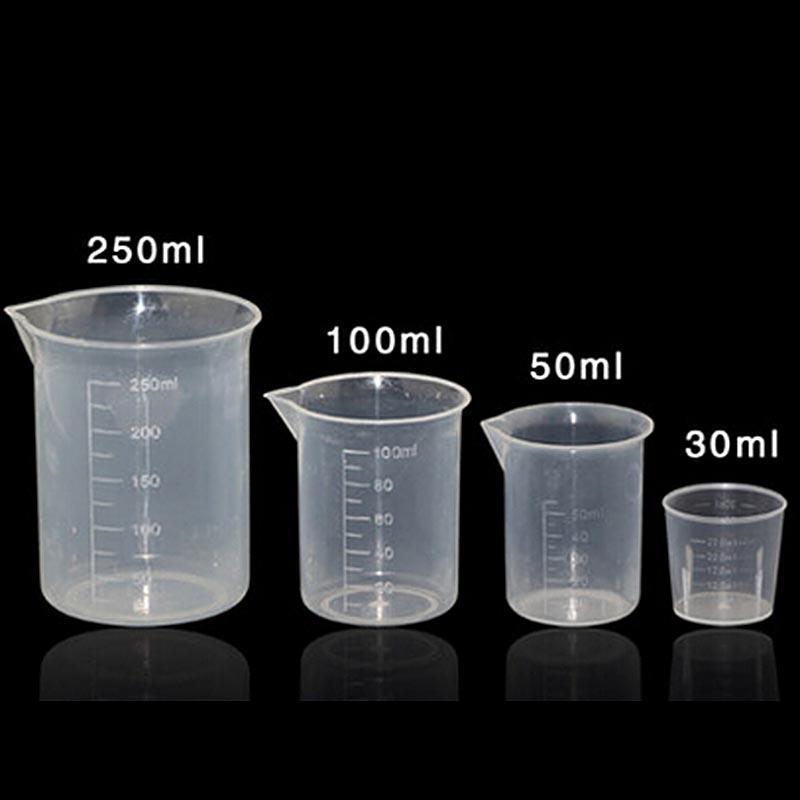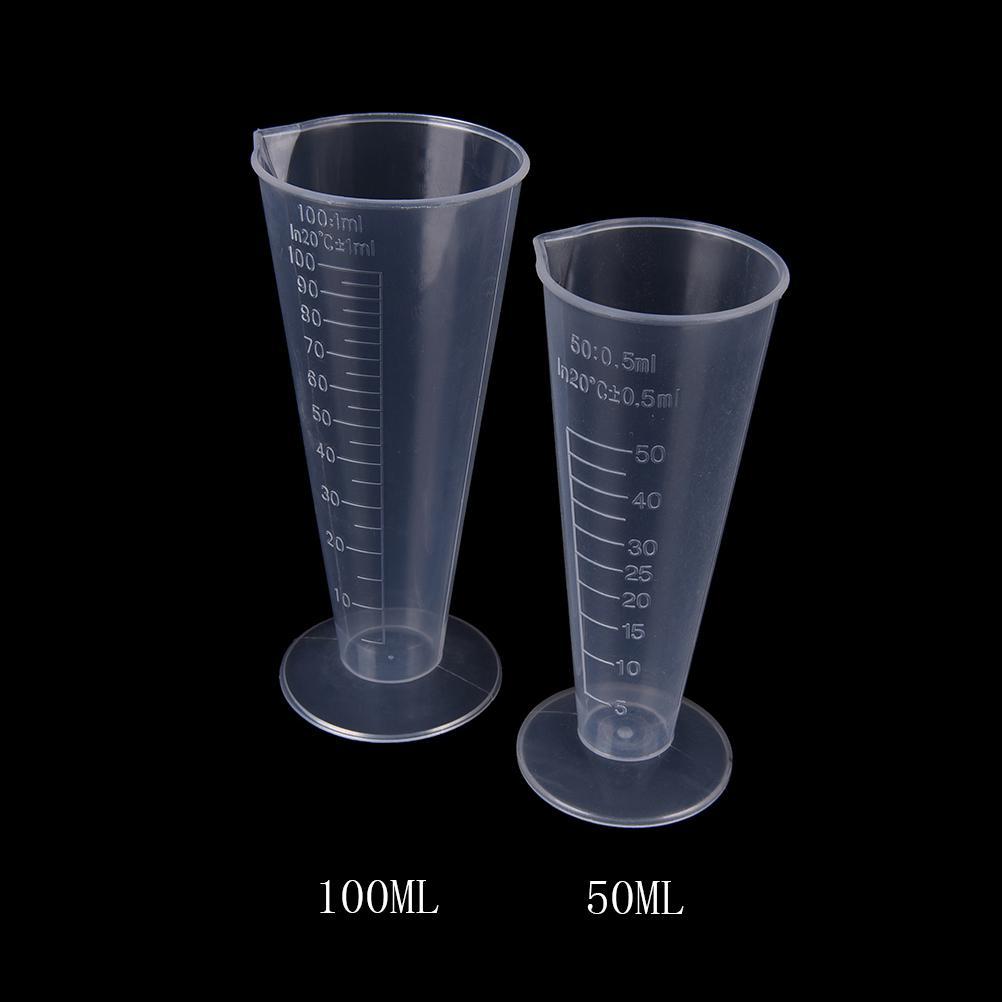The first image is the image on the left, the second image is the image on the right. For the images displayed, is the sentence "One image contains exactly 2 measuring cups." factually correct? Answer yes or no. Yes. 